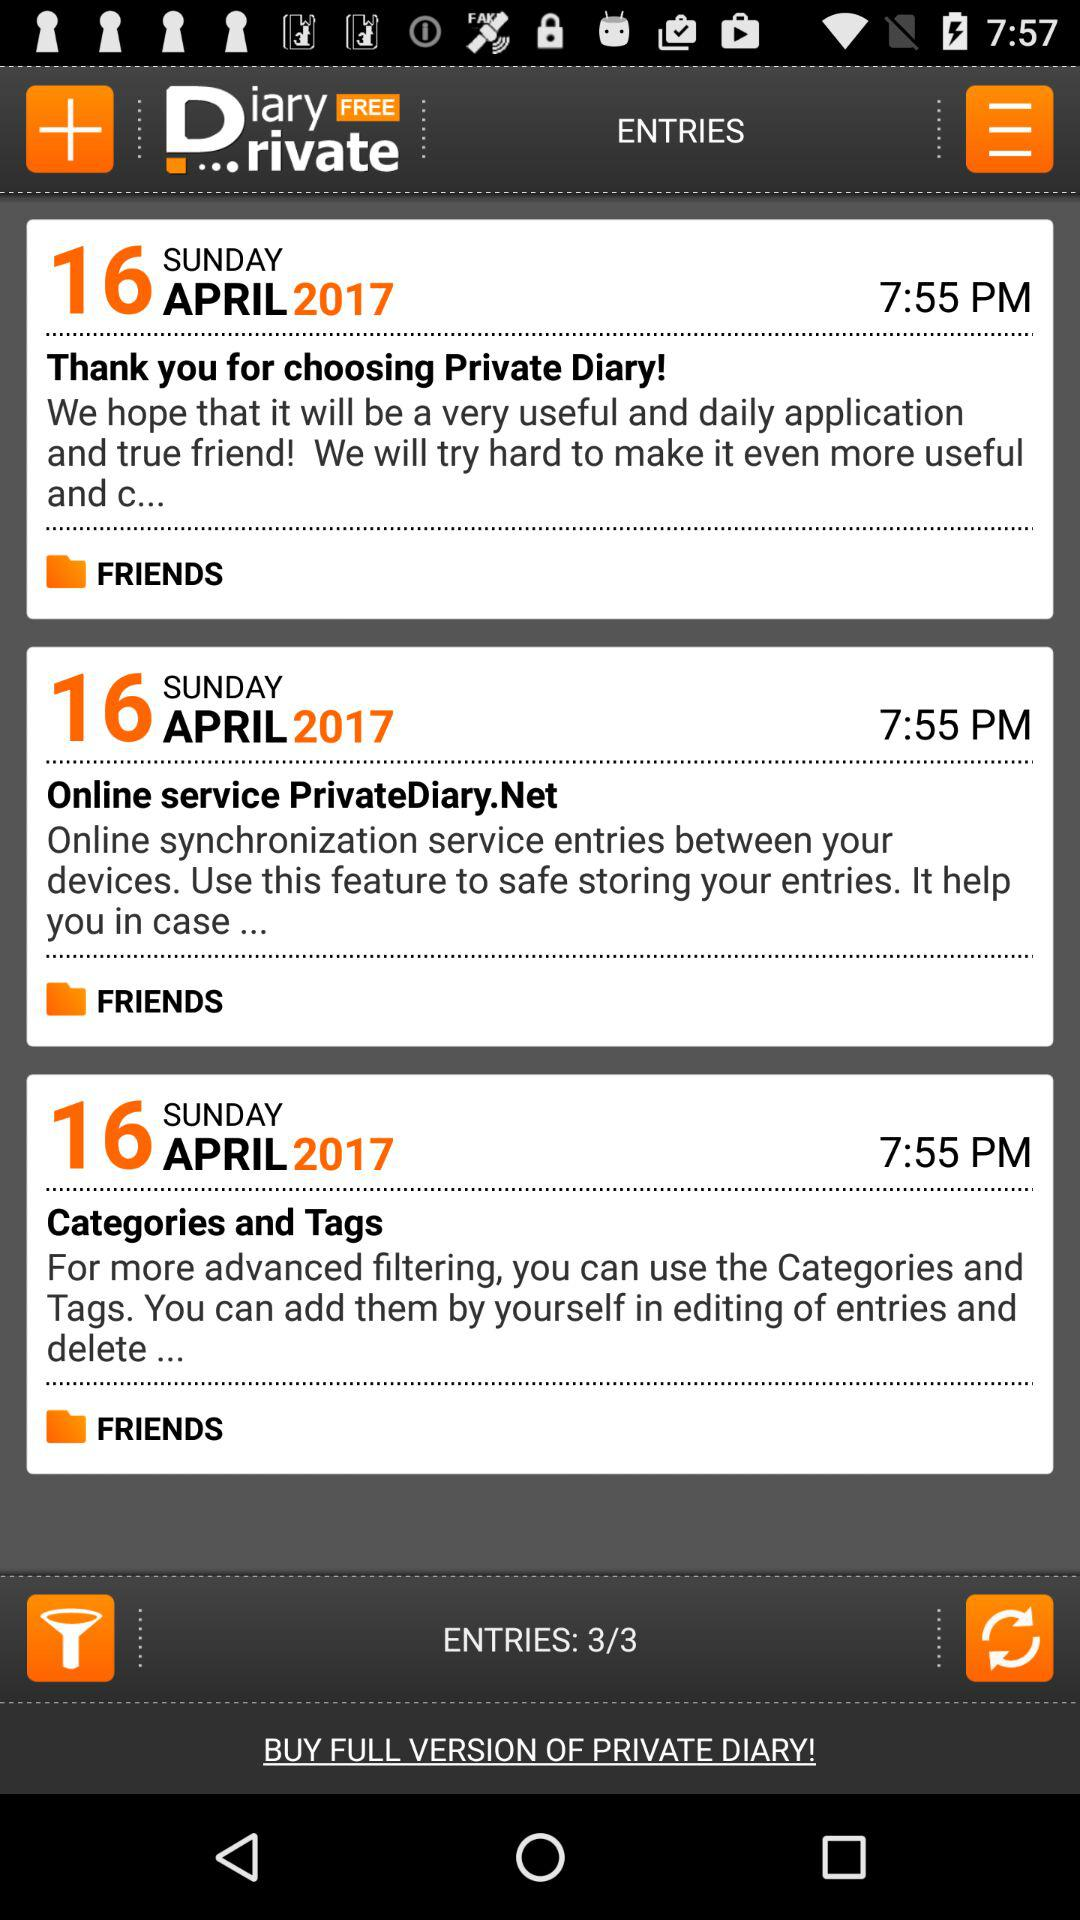On what date were "Categories and Tags" entries posted? "Categories and Tags" entries were posted on Sunday, April 16, 2017. 